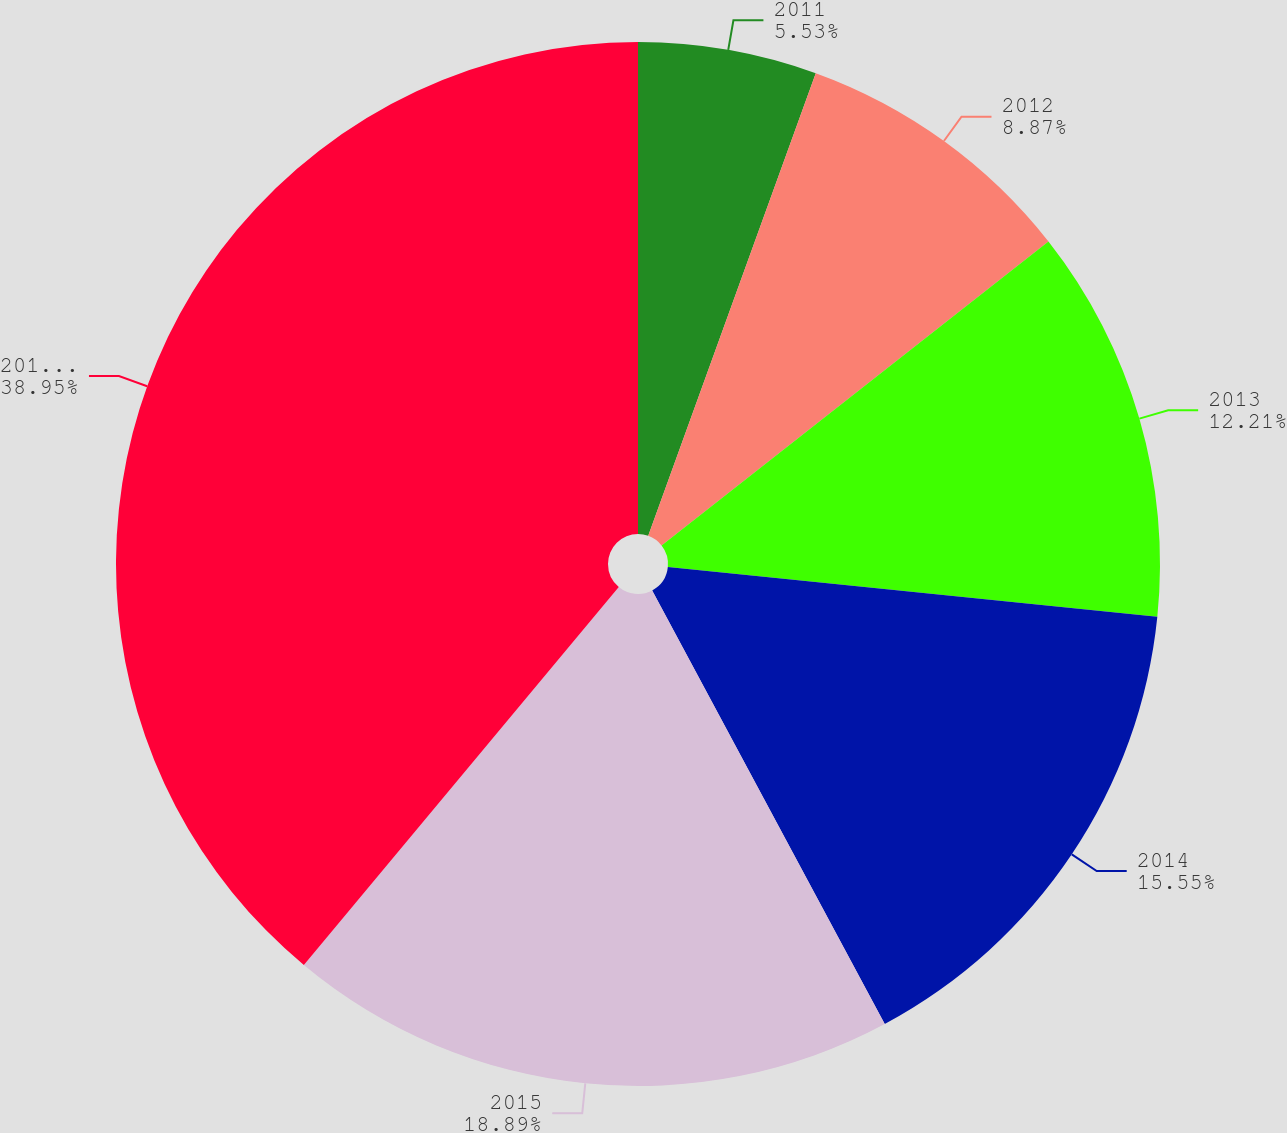Convert chart to OTSL. <chart><loc_0><loc_0><loc_500><loc_500><pie_chart><fcel>2011<fcel>2012<fcel>2013<fcel>2014<fcel>2015<fcel>2016-2020<nl><fcel>5.53%<fcel>8.87%<fcel>12.21%<fcel>15.55%<fcel>18.89%<fcel>38.94%<nl></chart> 